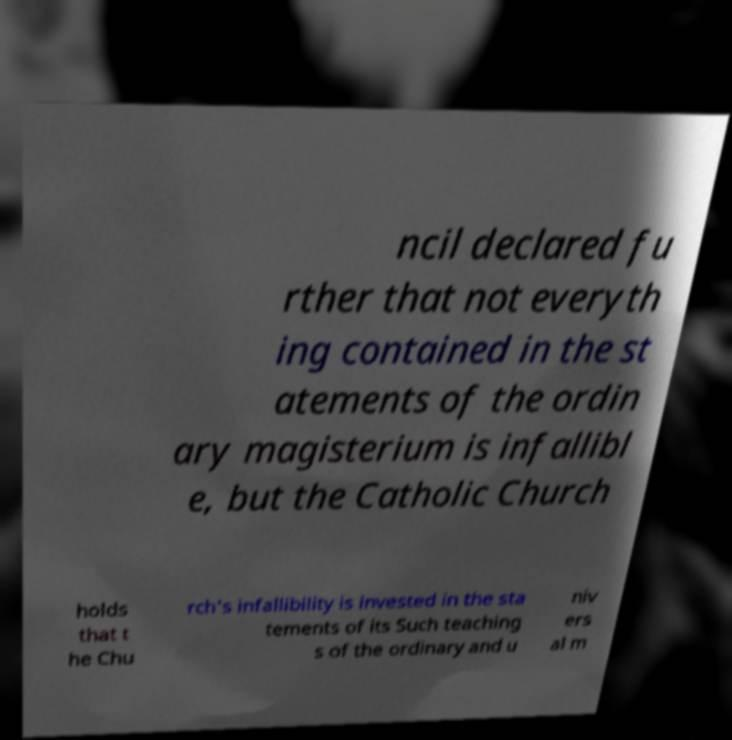Could you assist in decoding the text presented in this image and type it out clearly? ncil declared fu rther that not everyth ing contained in the st atements of the ordin ary magisterium is infallibl e, but the Catholic Church holds that t he Chu rch's infallibility is invested in the sta tements of its Such teaching s of the ordinary and u niv ers al m 